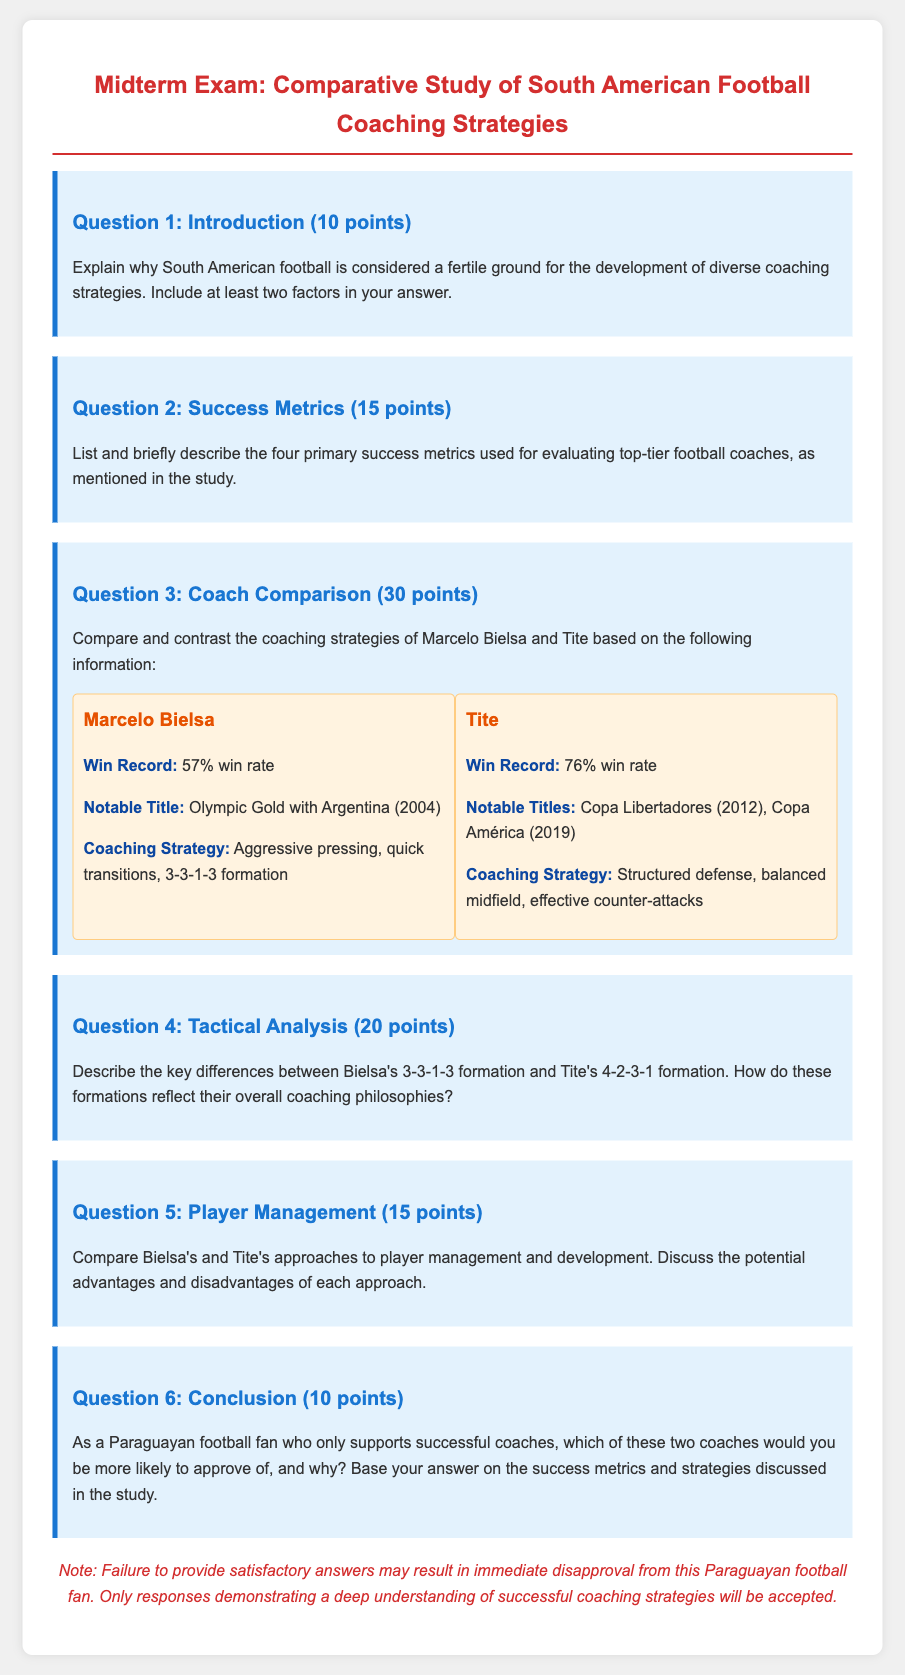What is the win rate of Tite? The win rate of Tite is stated as 76% in the document.
Answer: 76% What notable title did Marcelo Bielsa win? The document mentions that Marcelo Bielsa won the Olympic Gold with Argentina in 2004.
Answer: Olympic Gold with Argentina (2004) List one coaching strategy used by Bielsa. The document indicates that Bielsa's coaching strategy includes aggressive pressing.
Answer: Aggressive pressing What is one significant difference between Bielsa's and Tite's coaching strategies? The document describes Bielsa's strategy as aggressive pressing while Tite's strategy focuses on structured defense, highlighting their contrasting approaches.
Answer: Aggressive pressing vs. structured defense How many points is Question 1 worth? The document states that Question 1 is worth 10 points.
Answer: 10 points Which formation does Bielsa utilize? The document specifies that Bielsa's formation is 3-3-1-3.
Answer: 3-3-1-3 What is Tite's notable title? The document lists Tite's notable titles as Copa Libertadores (2012) and Copa América (2019).
Answer: Copa Libertadores (2012), Copa América (2019) How many points is the coach comparison question worth? The document indicates that the coach comparison question is worth 30 points.
Answer: 30 points In the conclusion question, what is required from students? The document states that students must justify their approval of a coach based on success metrics and strategies discussed in the study.
Answer: Justify their approval based on success metrics and strategies 